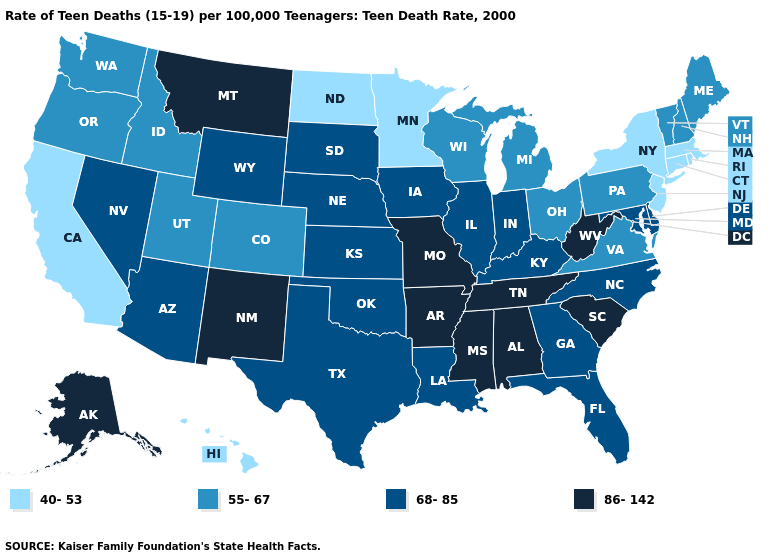Does Tennessee have the same value as Arkansas?
Be succinct. Yes. Which states have the highest value in the USA?
Keep it brief. Alabama, Alaska, Arkansas, Mississippi, Missouri, Montana, New Mexico, South Carolina, Tennessee, West Virginia. Which states have the highest value in the USA?
Concise answer only. Alabama, Alaska, Arkansas, Mississippi, Missouri, Montana, New Mexico, South Carolina, Tennessee, West Virginia. What is the value of Colorado?
Keep it brief. 55-67. Does Maryland have a lower value than Oregon?
Be succinct. No. What is the value of Arkansas?
Short answer required. 86-142. Name the states that have a value in the range 40-53?
Write a very short answer. California, Connecticut, Hawaii, Massachusetts, Minnesota, New Jersey, New York, North Dakota, Rhode Island. Does Nevada have the lowest value in the USA?
Concise answer only. No. What is the lowest value in states that border South Carolina?
Short answer required. 68-85. What is the lowest value in states that border Florida?
Be succinct. 68-85. What is the highest value in the USA?
Keep it brief. 86-142. Name the states that have a value in the range 68-85?
Short answer required. Arizona, Delaware, Florida, Georgia, Illinois, Indiana, Iowa, Kansas, Kentucky, Louisiana, Maryland, Nebraska, Nevada, North Carolina, Oklahoma, South Dakota, Texas, Wyoming. Does Connecticut have the highest value in the Northeast?
Quick response, please. No. Name the states that have a value in the range 86-142?
Write a very short answer. Alabama, Alaska, Arkansas, Mississippi, Missouri, Montana, New Mexico, South Carolina, Tennessee, West Virginia. How many symbols are there in the legend?
Be succinct. 4. 